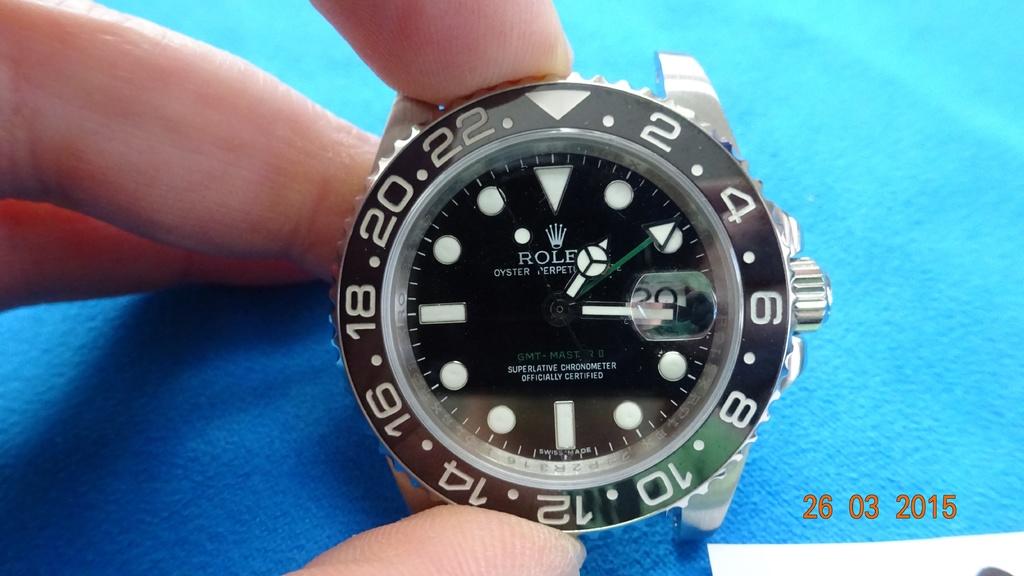What time is it?
Provide a short and direct response. 2:15. What brand is the watch?
Keep it short and to the point. Rolex. 